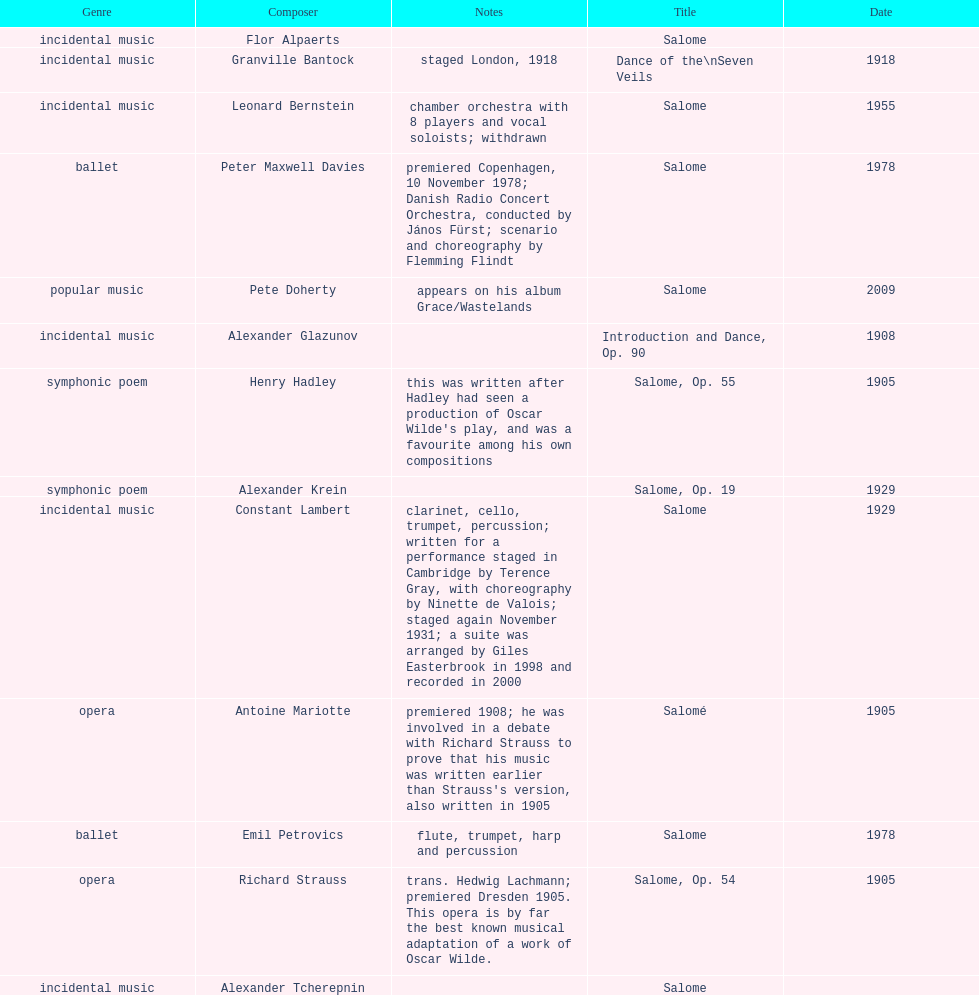Could you parse the entire table? {'header': ['Genre', 'Composer', 'Notes', 'Title', 'Date'], 'rows': [['incidental\xa0music', 'Flor Alpaerts', '', 'Salome', ''], ['incidental music', 'Granville Bantock', 'staged London, 1918', 'Dance of the\\nSeven Veils', '1918'], ['incidental music', 'Leonard Bernstein', 'chamber orchestra with 8 players and vocal soloists; withdrawn', 'Salome', '1955'], ['ballet', 'Peter\xa0Maxwell\xa0Davies', 'premiered Copenhagen, 10 November 1978; Danish Radio Concert Orchestra, conducted by János Fürst; scenario and choreography by Flemming Flindt', 'Salome', '1978'], ['popular music', 'Pete Doherty', 'appears on his album Grace/Wastelands', 'Salome', '2009'], ['incidental music', 'Alexander Glazunov', '', 'Introduction and Dance, Op. 90', '1908'], ['symphonic poem', 'Henry Hadley', "this was written after Hadley had seen a production of Oscar Wilde's play, and was a favourite among his own compositions", 'Salome, Op. 55', '1905'], ['symphonic poem', 'Alexander Krein', '', 'Salome, Op. 19', '1929'], ['incidental music', 'Constant Lambert', 'clarinet, cello, trumpet, percussion; written for a performance staged in Cambridge by Terence Gray, with choreography by Ninette de Valois; staged again November 1931; a suite was arranged by Giles Easterbrook in 1998 and recorded in 2000', 'Salome', '1929'], ['opera', 'Antoine Mariotte', "premiered 1908; he was involved in a debate with Richard Strauss to prove that his music was written earlier than Strauss's version, also written in 1905", 'Salomé', '1905'], ['ballet', 'Emil Petrovics', 'flute, trumpet, harp and percussion', 'Salome', '1978'], ['opera', 'Richard Strauss', 'trans. Hedwig Lachmann; premiered Dresden 1905. This opera is by far the best known musical adaptation of a work of Oscar Wilde.', 'Salome, Op. 54', '1905'], ['incidental music', 'Alexander\xa0Tcherepnin', '', 'Salome', '']]} Why type of genre was peter maxwell davies' work that was the same as emil petrovics' Ballet. 